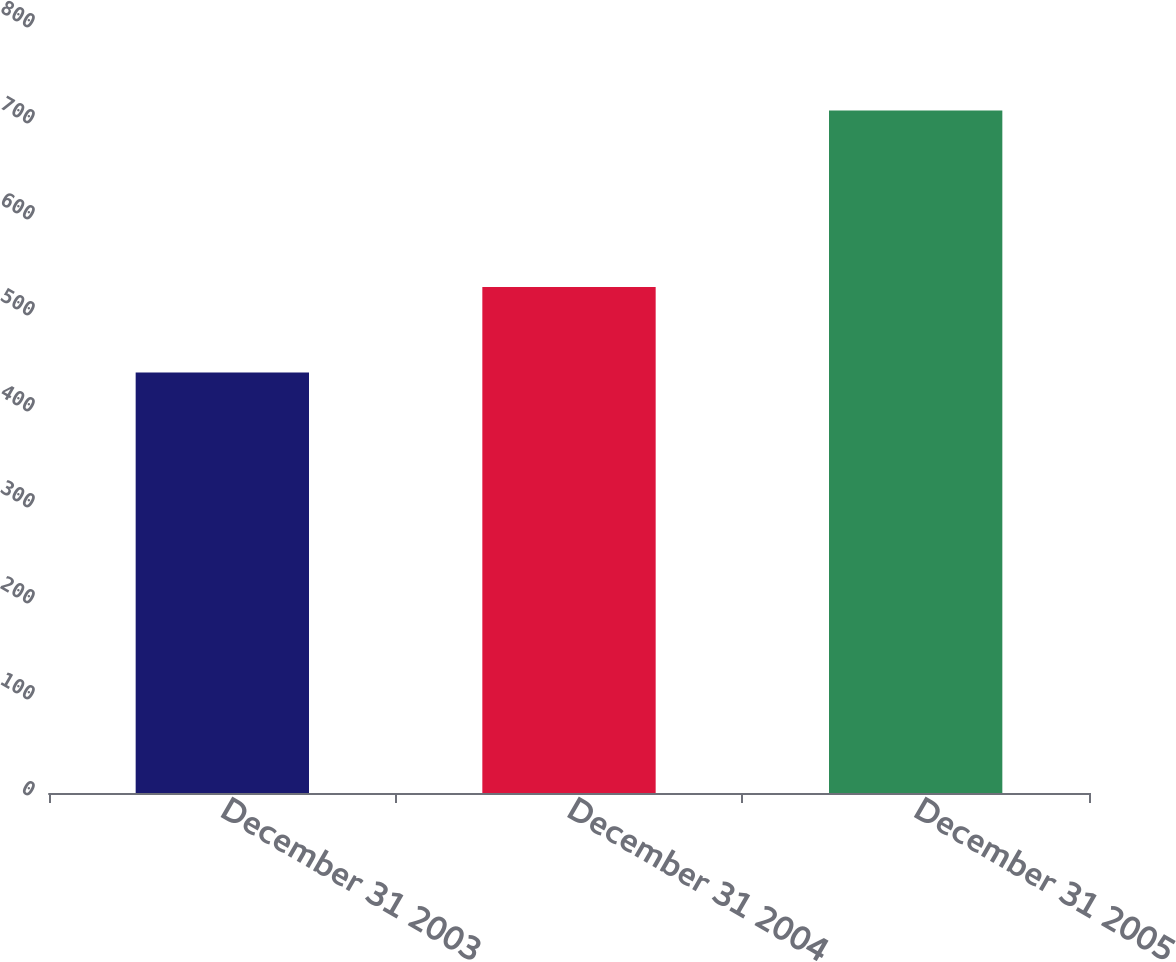<chart> <loc_0><loc_0><loc_500><loc_500><bar_chart><fcel>December 31 2003<fcel>December 31 2004<fcel>December 31 2005<nl><fcel>438<fcel>527<fcel>711<nl></chart> 